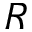<formula> <loc_0><loc_0><loc_500><loc_500>R</formula> 